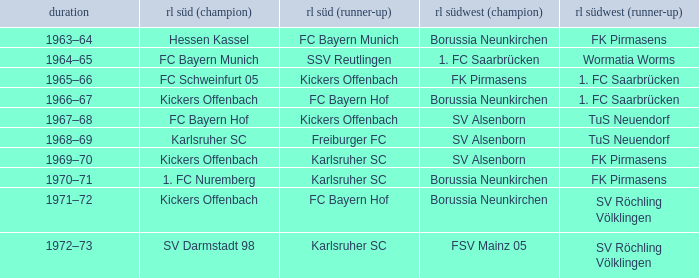In which season did sv darmstadt 98 finish first in rl süd? 1972–73. 